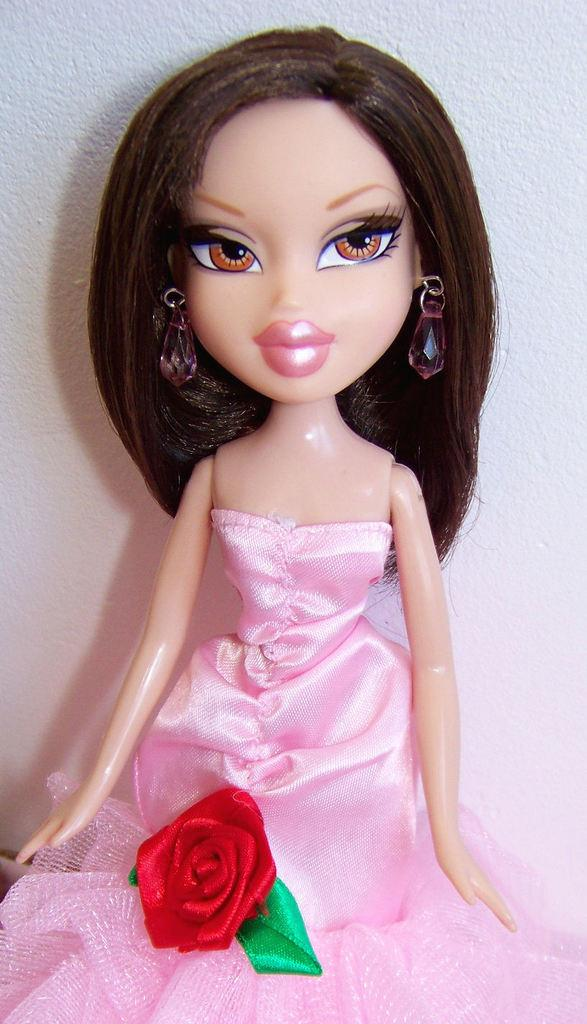What type of toy is in the image? There is a toy girl in the image. What is the toy girl wearing? The toy girl is wearing a pink gown. Are there any decorative elements on the gown? Yes, there is a red rose on the gown. What can be seen in the background of the image? There is a white wall in the background of the image. What is the toy girl thinking about in the image? The image does not provide any information about the toy girl's thoughts or emotions, so we cannot determine what she might be thinking about. 